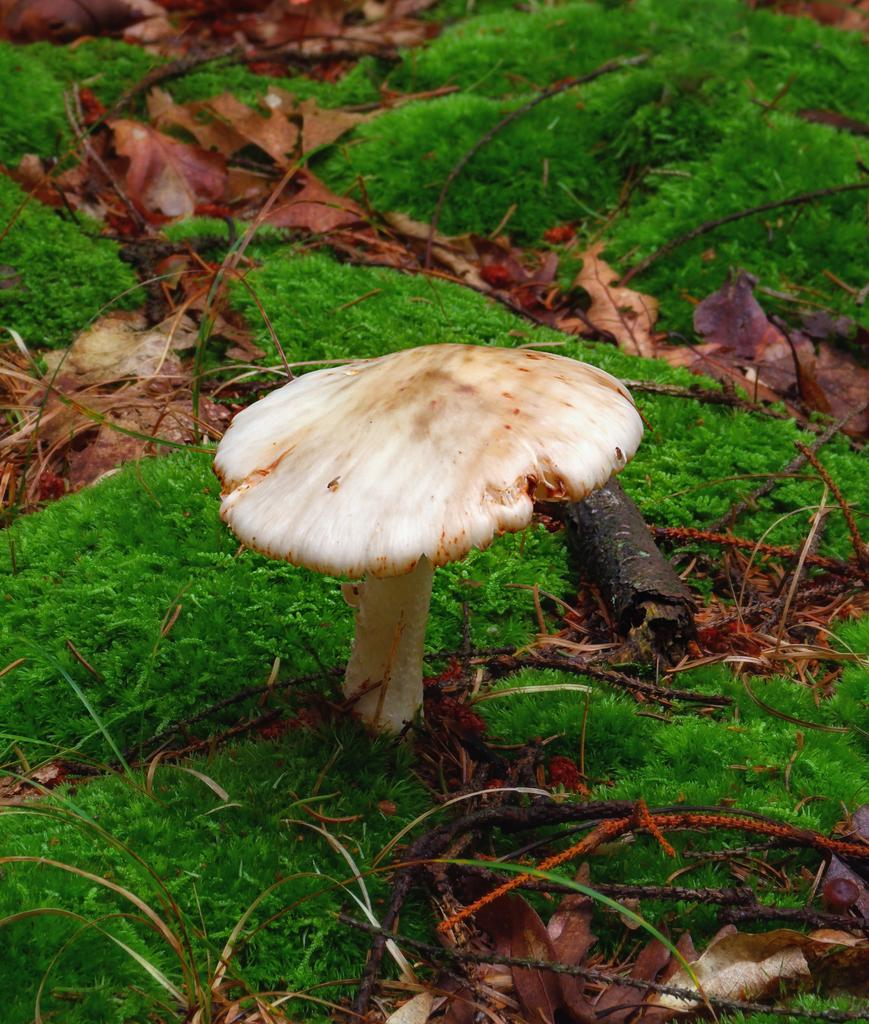What type of plant can be seen in the image? There is a mushroom in the image. What other natural elements are present in the image? There are leaves and sticks visible in the image. What type of ground cover is present in the image? There is grass visible in the image. What religious statement is being made by the mushroom in the image? There is no religious statement being made by the mushroom in the image, as it is a natural object and not capable of making statements. 